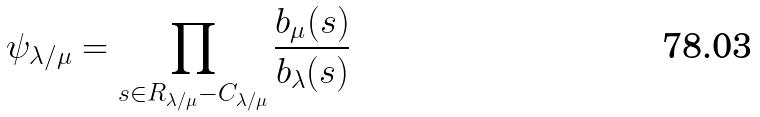<formula> <loc_0><loc_0><loc_500><loc_500>\psi _ { \lambda / \mu } = \prod _ { s \in R _ { \lambda / \mu } - C _ { \lambda / \mu } } \frac { b _ { \mu } ( s ) } { b _ { \lambda } ( s ) }</formula> 